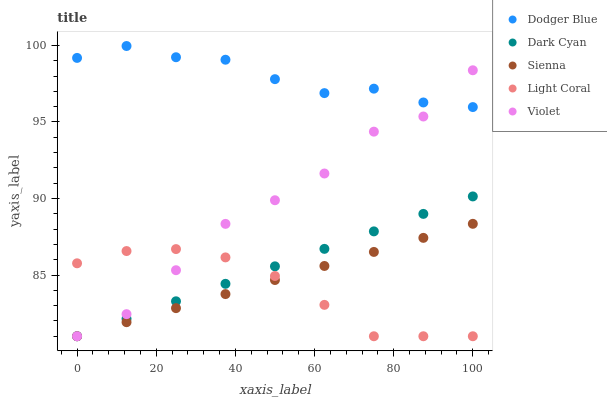Does Light Coral have the minimum area under the curve?
Answer yes or no. Yes. Does Dodger Blue have the maximum area under the curve?
Answer yes or no. Yes. Does Sienna have the minimum area under the curve?
Answer yes or no. No. Does Sienna have the maximum area under the curve?
Answer yes or no. No. Is Dark Cyan the smoothest?
Answer yes or no. Yes. Is Violet the roughest?
Answer yes or no. Yes. Is Dodger Blue the smoothest?
Answer yes or no. No. Is Dodger Blue the roughest?
Answer yes or no. No. Does Dark Cyan have the lowest value?
Answer yes or no. Yes. Does Dodger Blue have the lowest value?
Answer yes or no. No. Does Dodger Blue have the highest value?
Answer yes or no. Yes. Does Sienna have the highest value?
Answer yes or no. No. Is Light Coral less than Dodger Blue?
Answer yes or no. Yes. Is Dodger Blue greater than Sienna?
Answer yes or no. Yes. Does Light Coral intersect Violet?
Answer yes or no. Yes. Is Light Coral less than Violet?
Answer yes or no. No. Is Light Coral greater than Violet?
Answer yes or no. No. Does Light Coral intersect Dodger Blue?
Answer yes or no. No. 